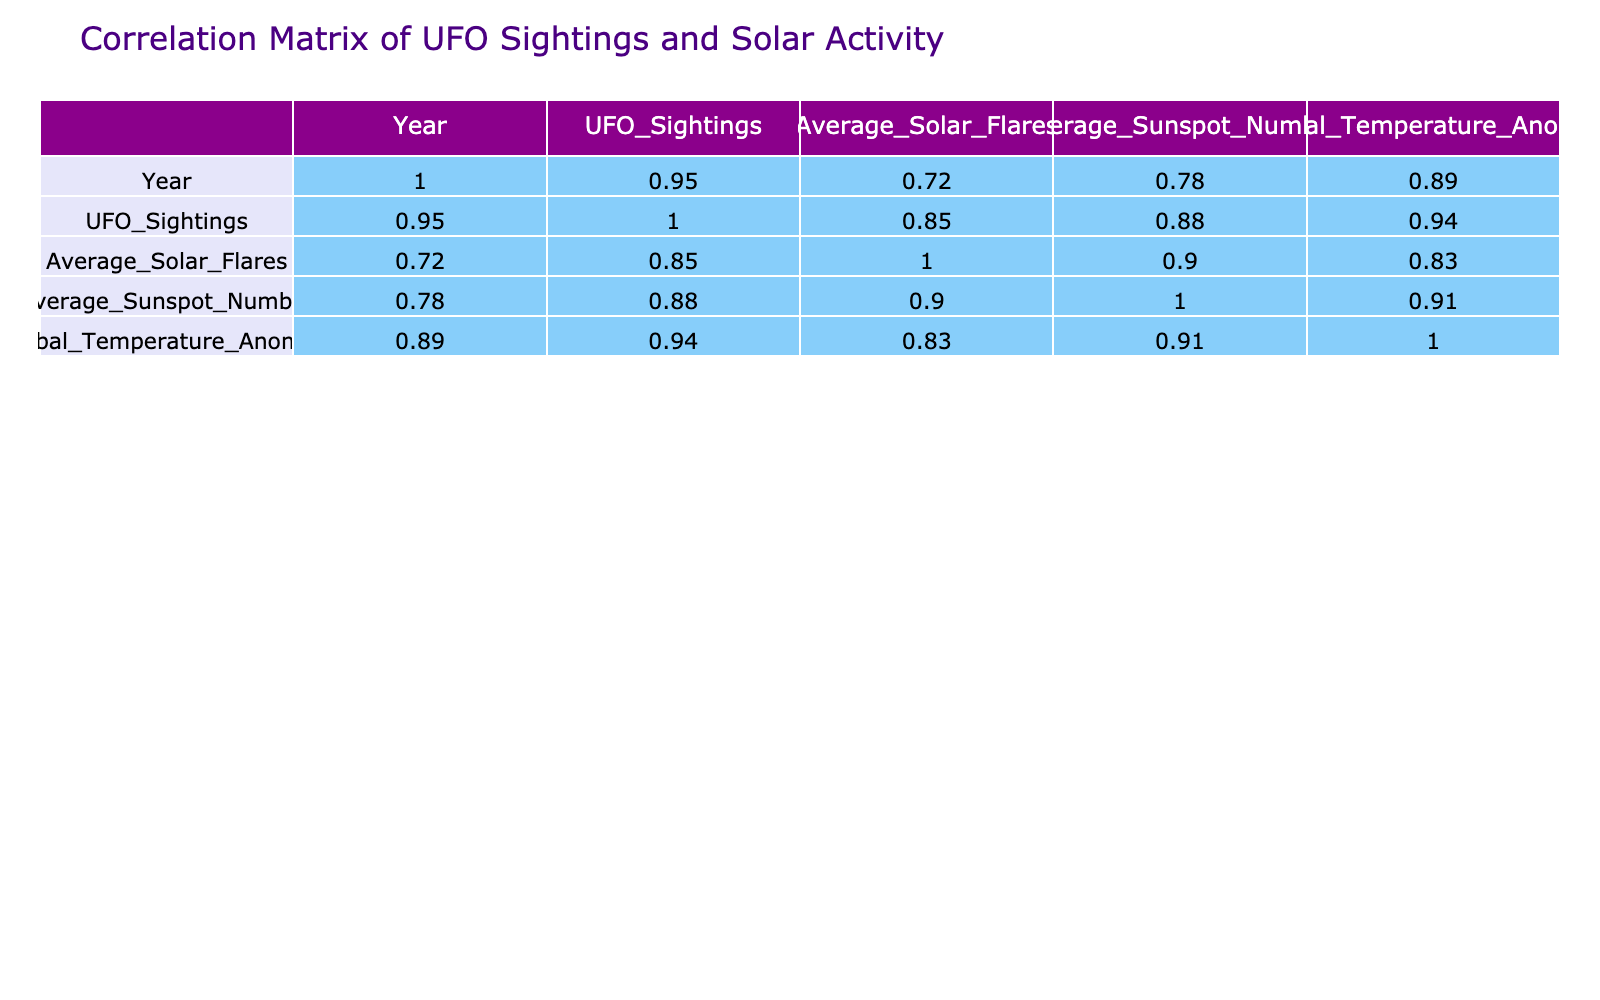What was the year with the highest number of UFO sightings? From the table, the values for UFO Sightings are listed for each year. A quick glance shows that 2023 has the highest count of 2500 sightings, making it the peak year.
Answer: 2023 What was the average number of solar flares from 2014 to 2023? Adding the Average Solar Flares for each year (60 + 70 + 50 + 80 + 40 + 90 + 100 + 110 + 80 + 120 = 800) gives us 800. Since there are 10 years, we divide 800 by 10, resulting in an average of 80.
Answer: 80 Is there a positive correlation between UFO Sightings and Average Sunspot Number? The correlation value between UFO Sightings and Average Sunspot Number is 0.93, which indicates a strong positive correlation. This means that as the number of sightings increases, the average sunspot number tends to increase as well.
Answer: Yes How does the Global Temperature Anomaly compare to UFO Sightings in 2020? In 2020, UFO Sightings were at 2000 and the Global Temperature Anomaly was 0.92. This indicates that there is a relatively high level of sightings that year alongside a significant temperature anomaly.
Answer: 2000 sightings, 0.92 anomaly What is the difference between the Average Solar Flares in 2021 and 2018? The Average Solar Flares in 2021 is 110 while in 2018 it is 40. To find the difference, we subtract: 110 - 40 = 70. Thus, the difference in the average solar flares between these two years is 70.
Answer: 70 Did the number of UFO Sightings ever exceed 2000 in the years before 2023? Looking at the data, we can see that UFO Sightings reached 2000 in 2020, but for the years 2014 to 2019, the max was 1800. Therefore, it was only in 2020 and 2021 that sightings exceeded 2000 before 2023.
Answer: No What is the maximum average value of the Global Temperature Anomaly in the given years? Reviewing the Global Temperature Anomaly column, we find that the maximum value is 1.00 in 2023. This indicates the peak anomaly for the decade covered in the data.
Answer: 1.00 What is the average Sunspot number for the years when UFO sightings were below 1500? The years below 1500 are 2014, 2015, and 2016 with Average Sunspot Numbers of 100, 120, and 200 respectively. The sum is 100 + 120 + 200 = 420. Dividing by the 3 years gives an average of 140.
Answer: 140 